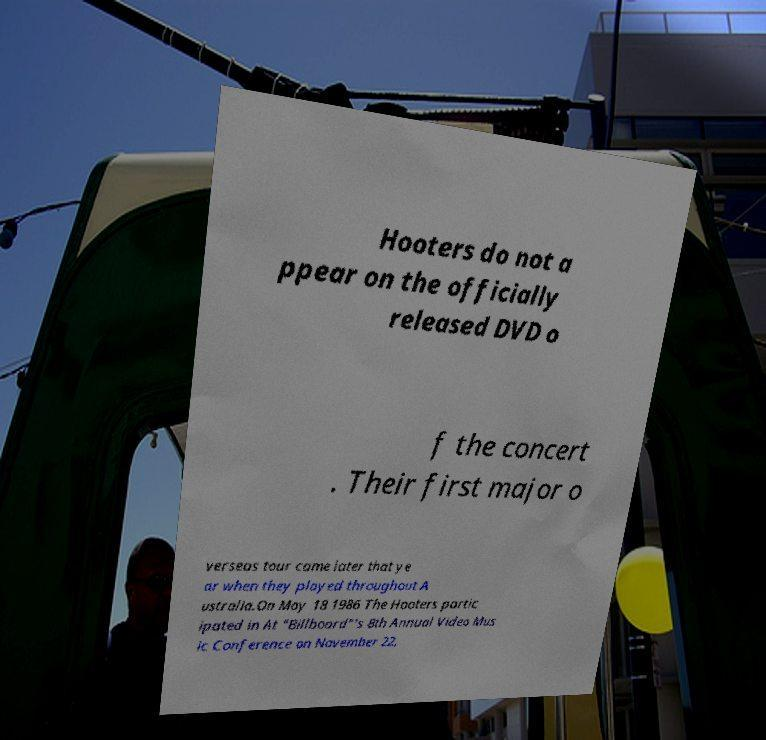Could you assist in decoding the text presented in this image and type it out clearly? Hooters do not a ppear on the officially released DVD o f the concert . Their first major o verseas tour came later that ye ar when they played throughout A ustralia.On May 18 1986 The Hooters partic ipated in At "Billboard"'s 8th Annual Video Mus ic Conference on November 22, 